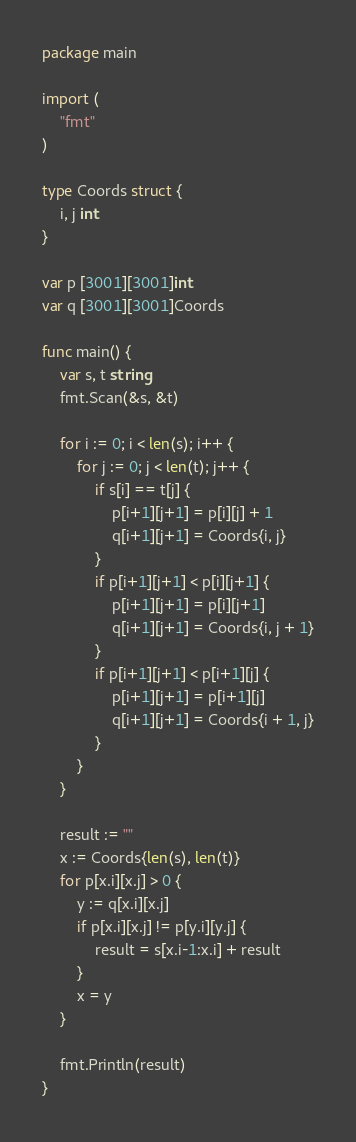Convert code to text. <code><loc_0><loc_0><loc_500><loc_500><_Go_>package main

import (
	"fmt"
)

type Coords struct {
	i, j int
}

var p [3001][3001]int
var q [3001][3001]Coords

func main() {
	var s, t string
	fmt.Scan(&s, &t)

	for i := 0; i < len(s); i++ {
		for j := 0; j < len(t); j++ {
			if s[i] == t[j] {
				p[i+1][j+1] = p[i][j] + 1
				q[i+1][j+1] = Coords{i, j}
			}
			if p[i+1][j+1] < p[i][j+1] {
				p[i+1][j+1] = p[i][j+1]
				q[i+1][j+1] = Coords{i, j + 1}
			}
			if p[i+1][j+1] < p[i+1][j] {
				p[i+1][j+1] = p[i+1][j]
				q[i+1][j+1] = Coords{i + 1, j}
			}
		}
	}

	result := ""
	x := Coords{len(s), len(t)}
	for p[x.i][x.j] > 0 {
		y := q[x.i][x.j]
		if p[x.i][x.j] != p[y.i][y.j] {
			result = s[x.i-1:x.i] + result
		}
		x = y
	}

	fmt.Println(result)
}
</code> 